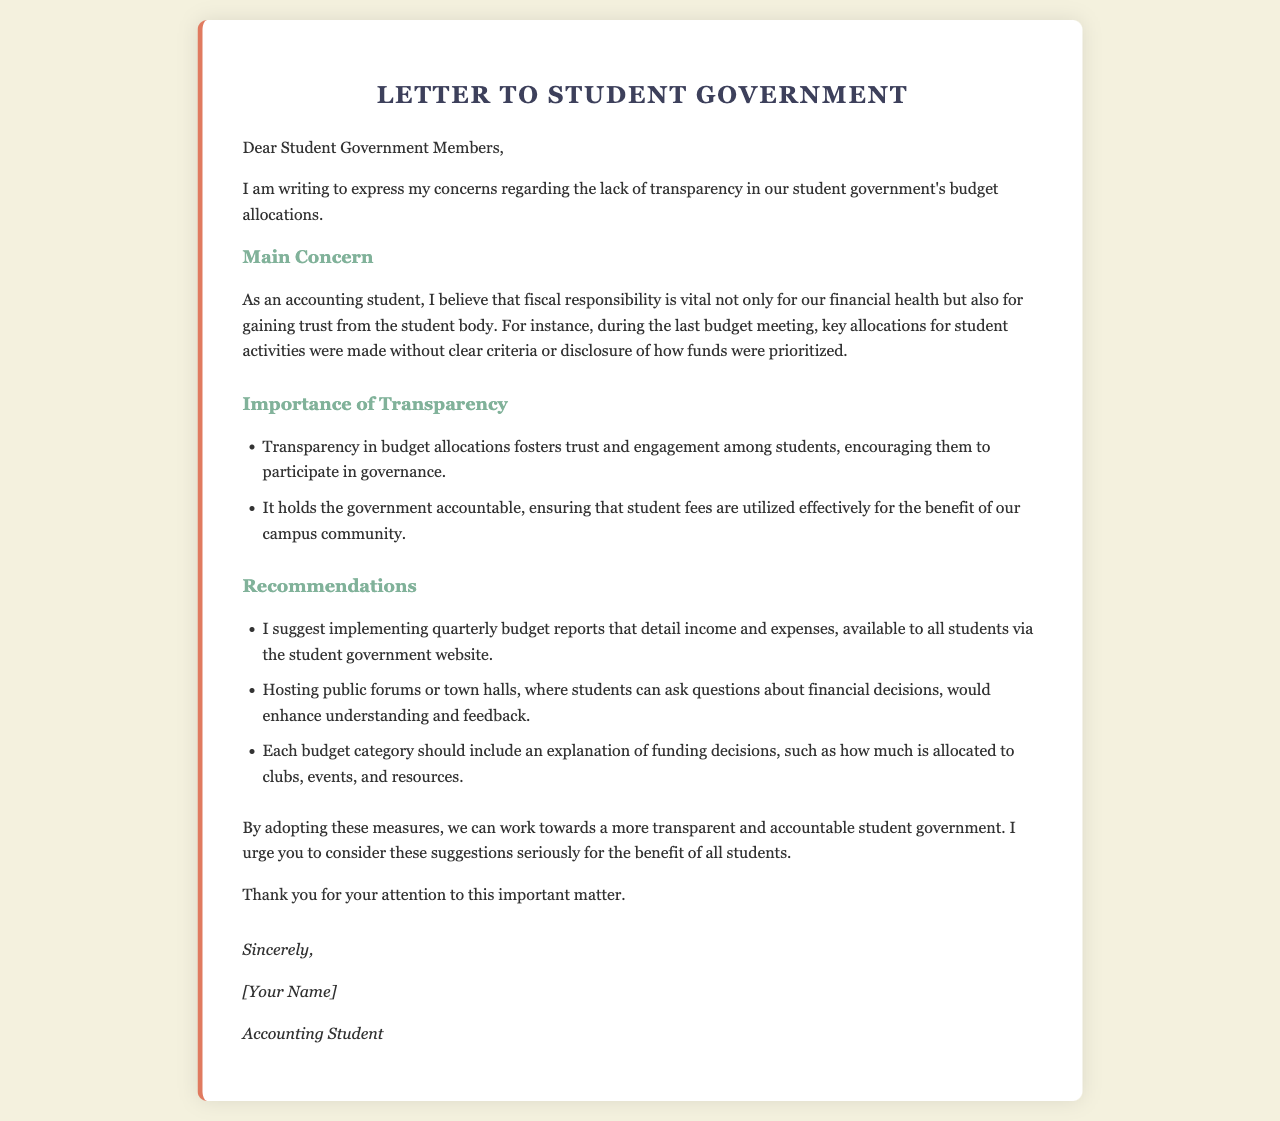What is the main concern addressed in the letter? The main concern is the lack of transparency in budget allocations made by the student government.
Answer: Lack of transparency in budget allocations What profession does the author identify with? The author identifies as an accounting student, indicating a relevant background for the concerns raised.
Answer: Accounting student What is the first recommendation made in the letter? The first recommendation is to implement quarterly budget reports that detail income and expenses.
Answer: Implement quarterly budget reports What advantage of transparency is mentioned? Transparency in budget allocations fosters trust and engagement among students.
Answer: Fosters trust and engagement How many suggestions are provided in the recommendations section? There are three suggestions provided for improving transparency in budget allocations.
Answer: Three suggestions What is the purpose of hosting public forums according to the letter? Hosting public forums would enhance understanding and feedback from students about financial decisions.
Answer: Enhance understanding and feedback How does the author sign off the letter? The author signs off with "Sincerely," followed by their name and profession.
Answer: Sincerely, [Your Name], Accounting Student What color is used for the section title of "Importance of Transparency"? The color used for the section title is a shade of green, indicated by the color code.
Answer: Green 